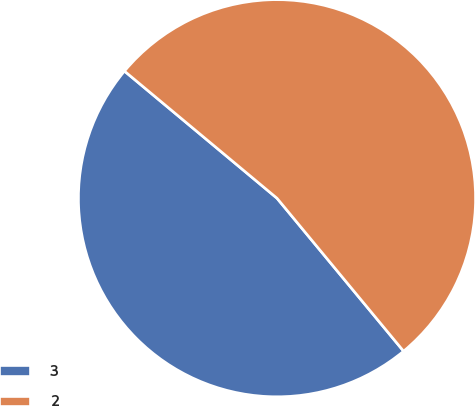Convert chart to OTSL. <chart><loc_0><loc_0><loc_500><loc_500><pie_chart><fcel>3<fcel>2<nl><fcel>47.06%<fcel>52.94%<nl></chart> 